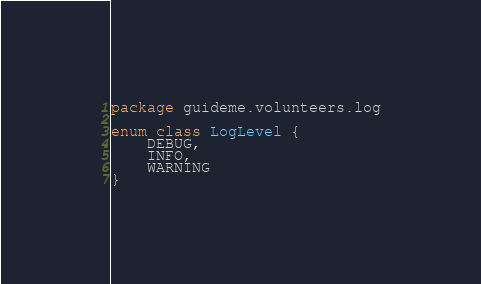<code> <loc_0><loc_0><loc_500><loc_500><_Kotlin_>package guideme.volunteers.log

enum class LogLevel {
    DEBUG,
    INFO,
    WARNING
}</code> 